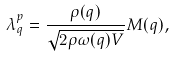Convert formula to latex. <formula><loc_0><loc_0><loc_500><loc_500>\lambda _ { q } ^ { p } = \frac { \rho ( q ) } { \sqrt { 2 \rho \omega ( q ) V } } M ( q ) ,</formula> 